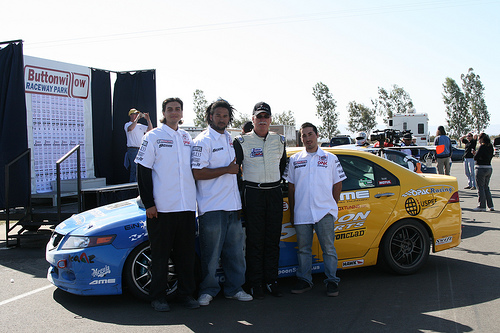<image>
Is the man behind the car? No. The man is not behind the car. From this viewpoint, the man appears to be positioned elsewhere in the scene. Is there a man next to the other man? No. The man is not positioned next to the other man. They are located in different areas of the scene. Where is the men in relation to the car? Is it in front of the car? Yes. The men is positioned in front of the car, appearing closer to the camera viewpoint. 